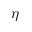Convert formula to latex. <formula><loc_0><loc_0><loc_500><loc_500>\eta</formula> 